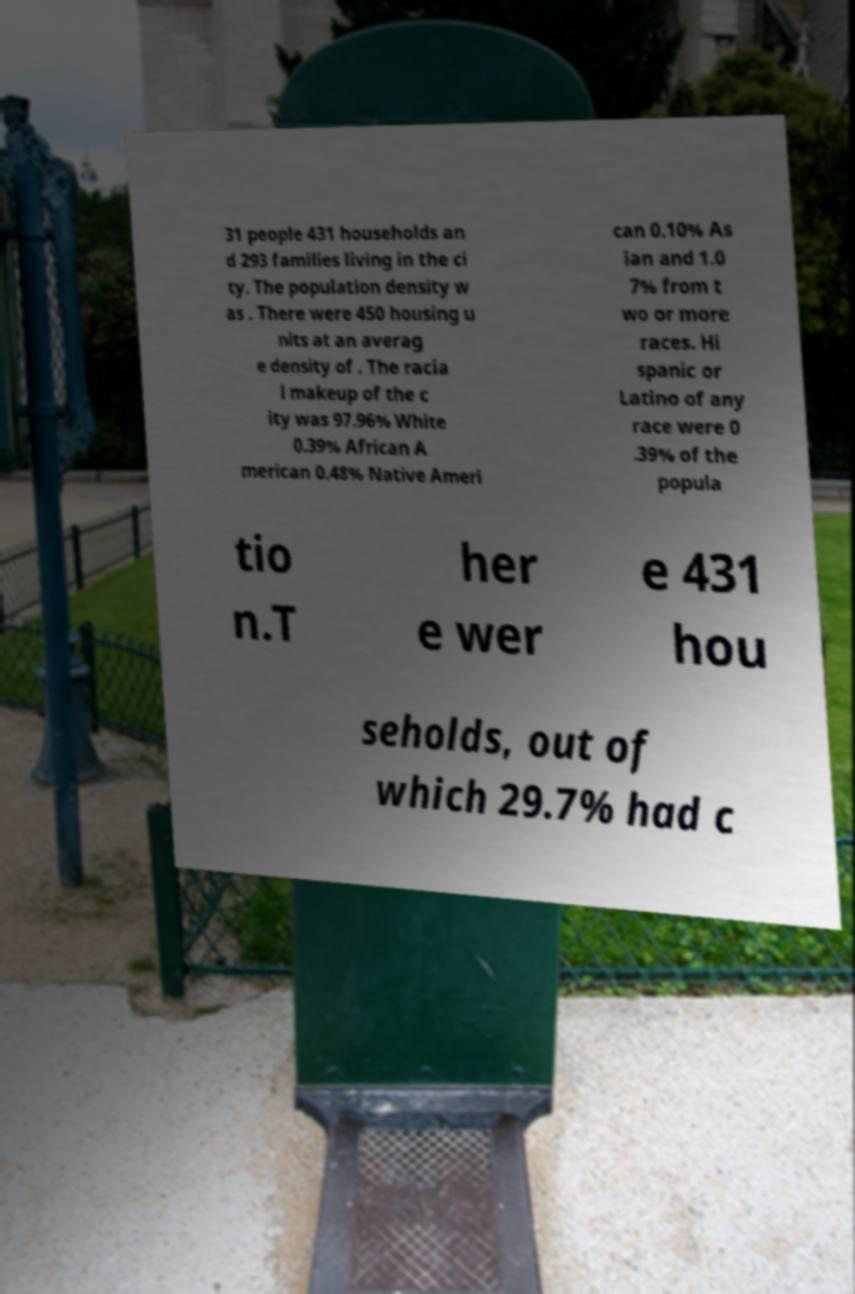For documentation purposes, I need the text within this image transcribed. Could you provide that? 31 people 431 households an d 293 families living in the ci ty. The population density w as . There were 450 housing u nits at an averag e density of . The racia l makeup of the c ity was 97.96% White 0.39% African A merican 0.48% Native Ameri can 0.10% As ian and 1.0 7% from t wo or more races. Hi spanic or Latino of any race were 0 .39% of the popula tio n.T her e wer e 431 hou seholds, out of which 29.7% had c 